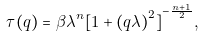<formula> <loc_0><loc_0><loc_500><loc_500>\tau ( q ) = \beta { \lambda } ^ { n } { [ 1 + { ( q \lambda ) } ^ { 2 } ] } ^ { - \frac { n + 1 } { 2 } } ,</formula> 